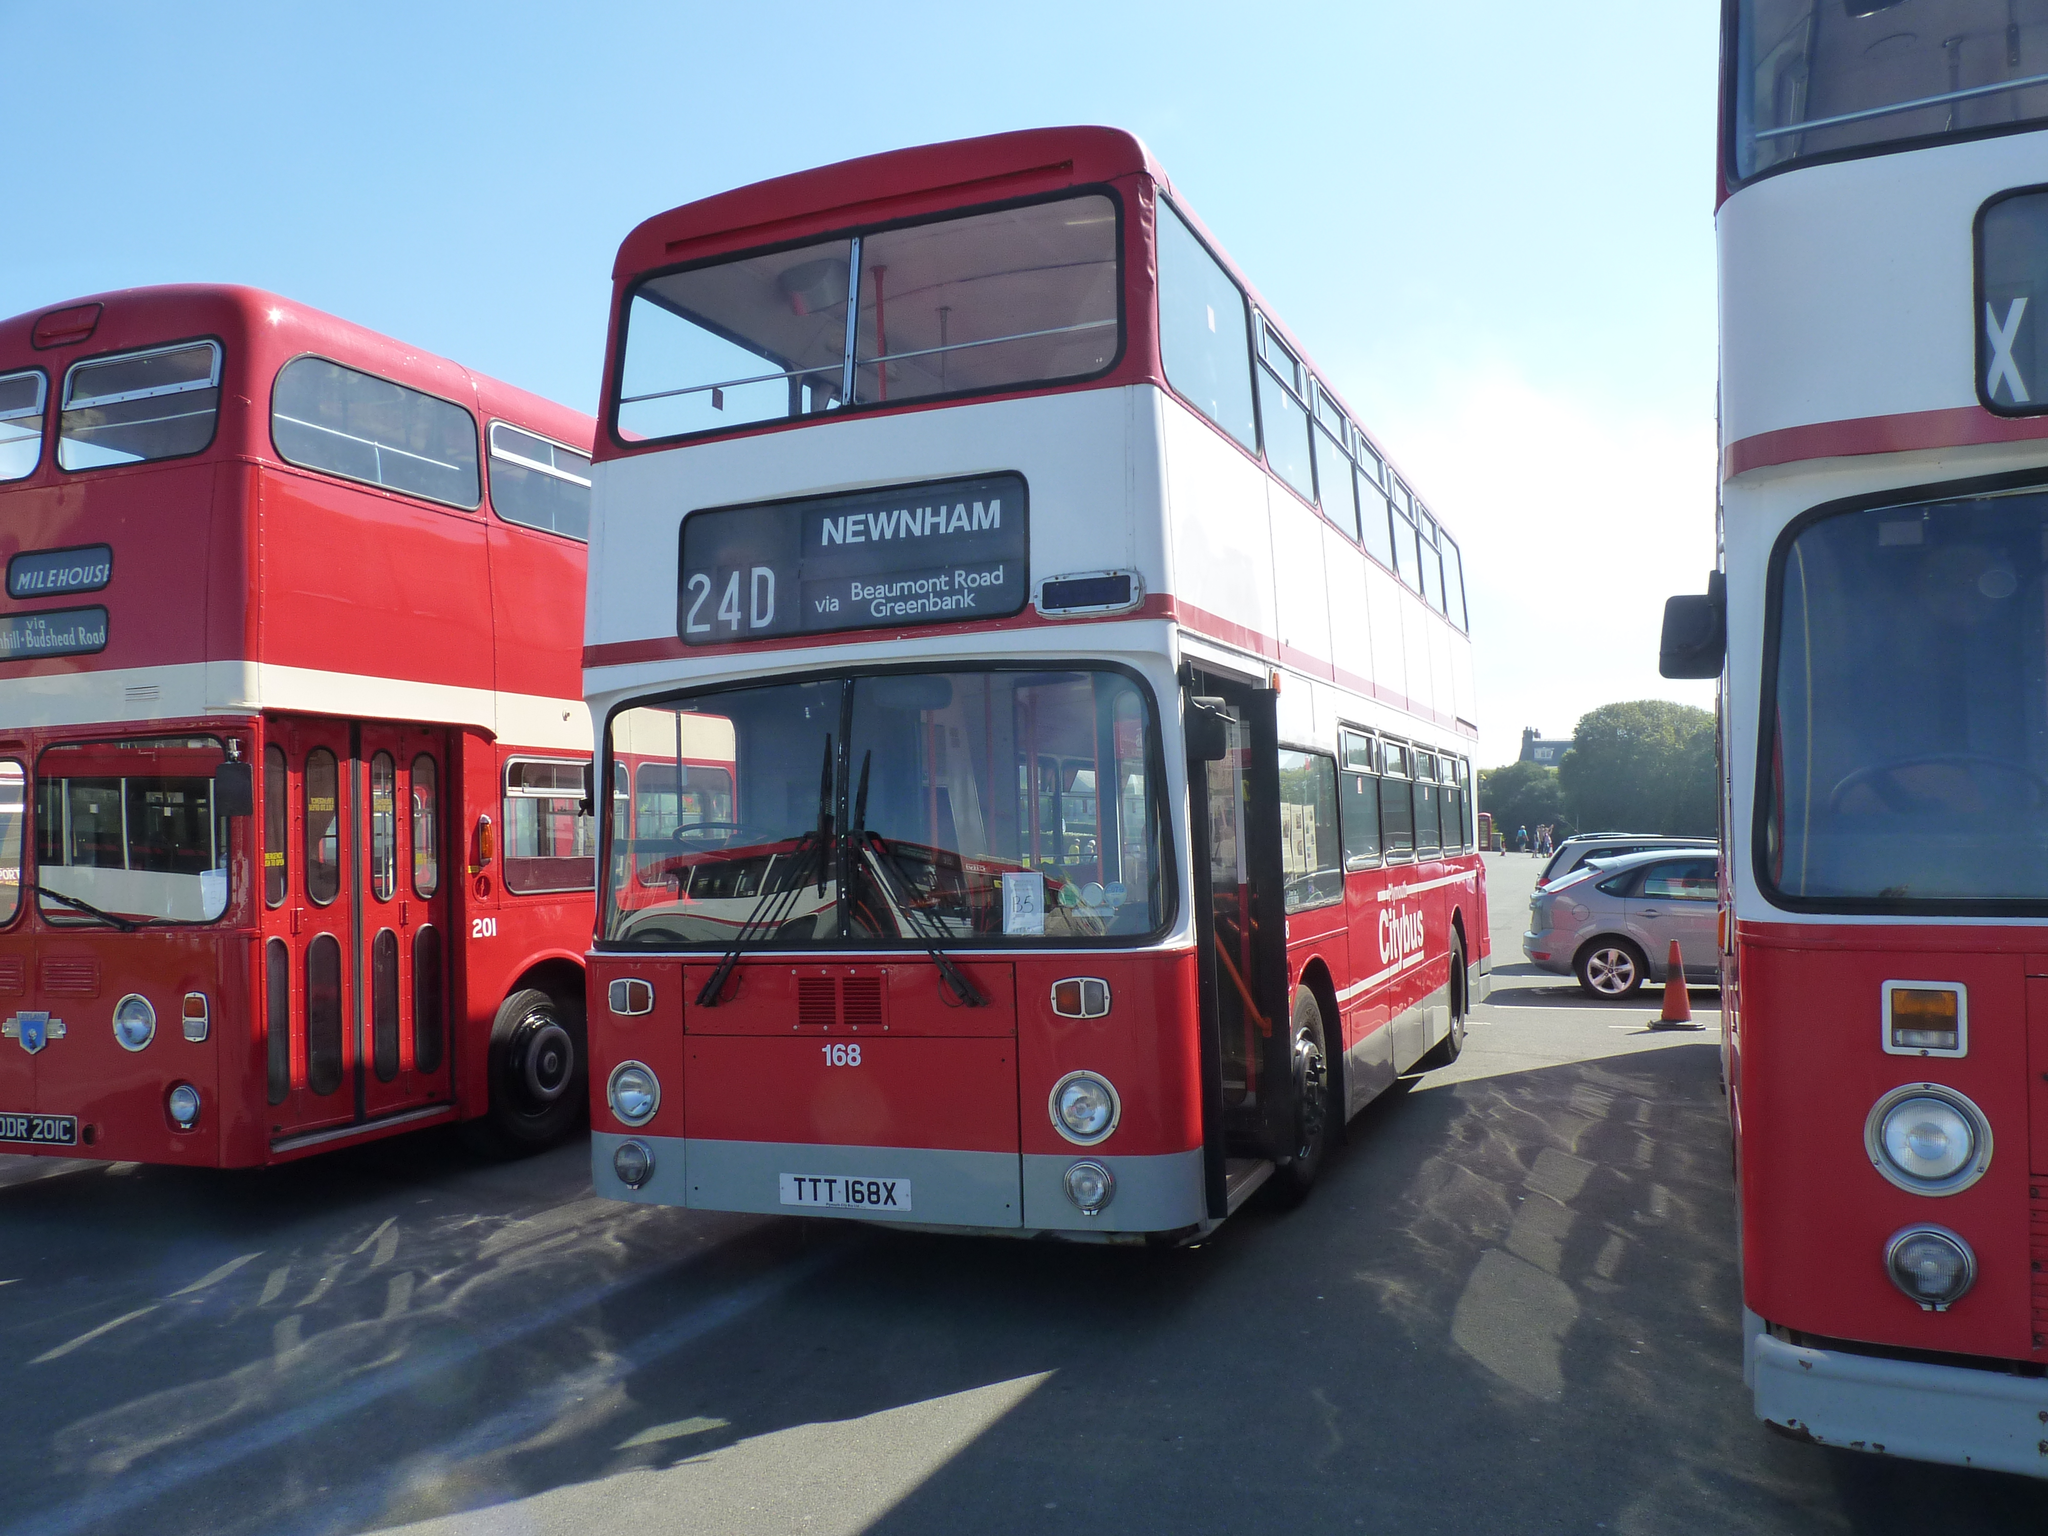<image>
Present a compact description of the photo's key features. A Newham bus with the number 24D sits between two other buses. 